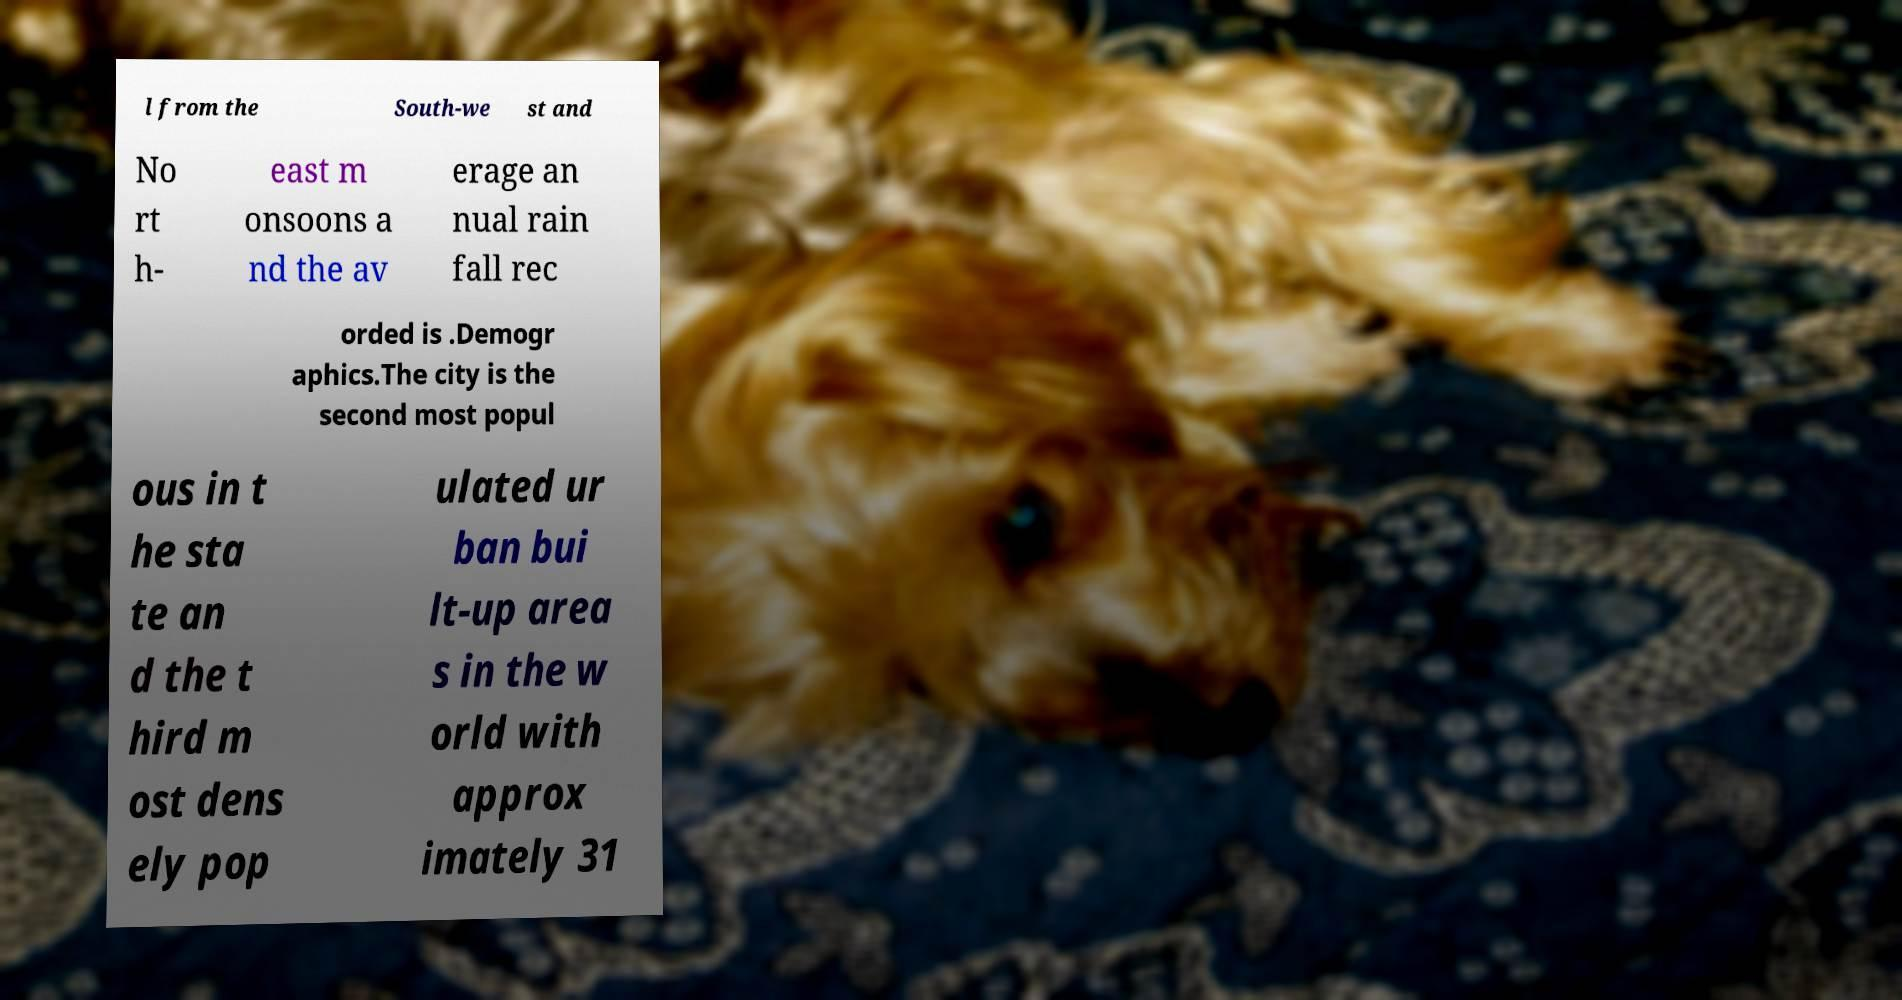Please read and relay the text visible in this image. What does it say? l from the South-we st and No rt h- east m onsoons a nd the av erage an nual rain fall rec orded is .Demogr aphics.The city is the second most popul ous in t he sta te an d the t hird m ost dens ely pop ulated ur ban bui lt-up area s in the w orld with approx imately 31 